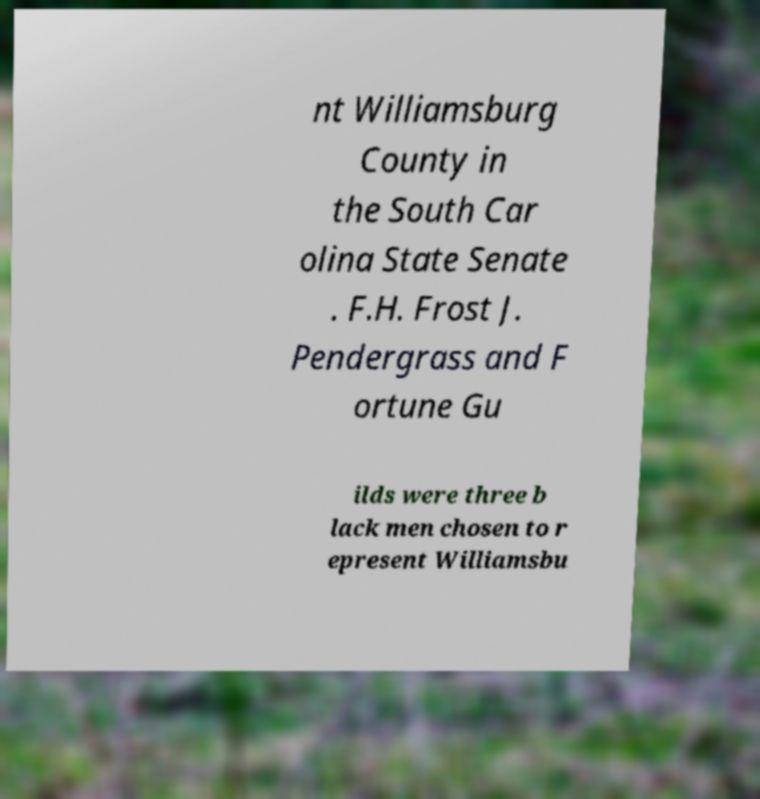Please identify and transcribe the text found in this image. nt Williamsburg County in the South Car olina State Senate . F.H. Frost J. Pendergrass and F ortune Gu ilds were three b lack men chosen to r epresent Williamsbu 